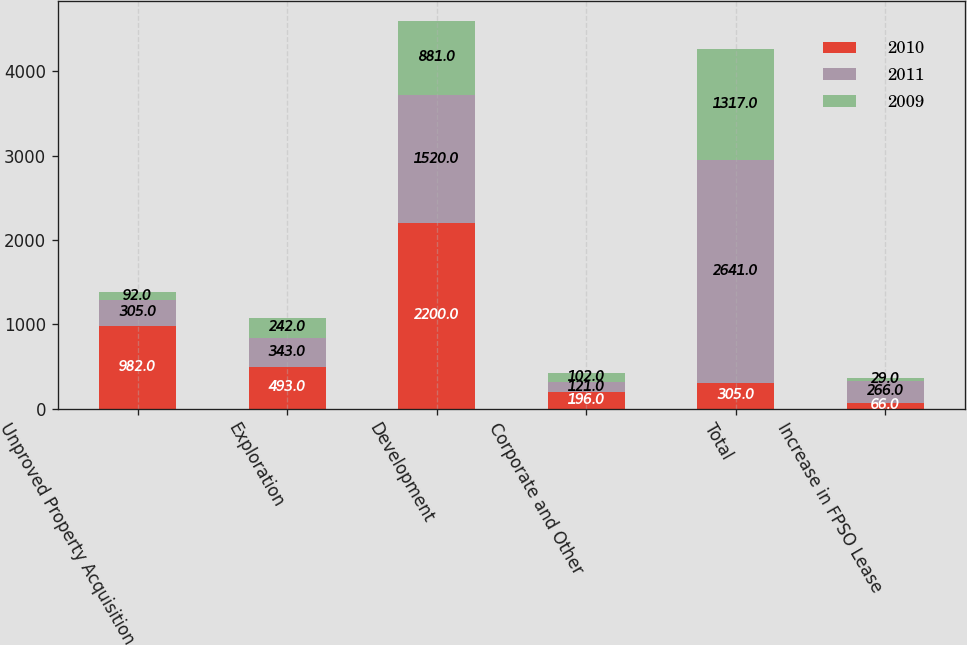<chart> <loc_0><loc_0><loc_500><loc_500><stacked_bar_chart><ecel><fcel>Unproved Property Acquisition<fcel>Exploration<fcel>Development<fcel>Corporate and Other<fcel>Total<fcel>Increase in FPSO Lease<nl><fcel>2010<fcel>982<fcel>493<fcel>2200<fcel>196<fcel>305<fcel>66<nl><fcel>2011<fcel>305<fcel>343<fcel>1520<fcel>121<fcel>2641<fcel>266<nl><fcel>2009<fcel>92<fcel>242<fcel>881<fcel>102<fcel>1317<fcel>29<nl></chart> 